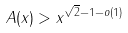Convert formula to latex. <formula><loc_0><loc_0><loc_500><loc_500>A ( x ) > x ^ { \sqrt { 2 } - 1 - o ( 1 ) }</formula> 